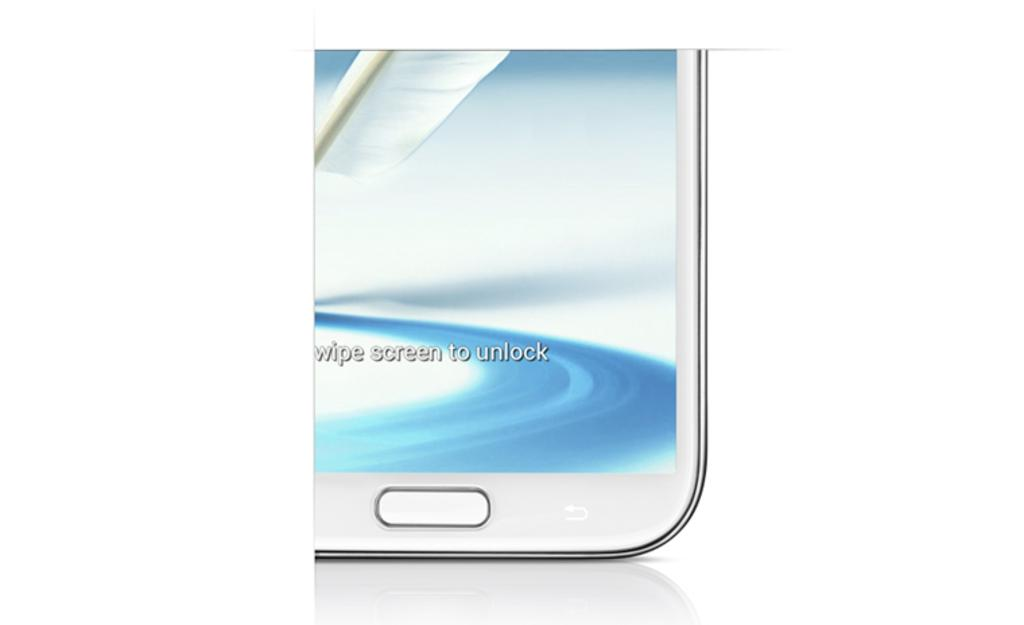<image>
Relay a brief, clear account of the picture shown. A picture of a partial phone shot with wipe screen to unlock displayed. 